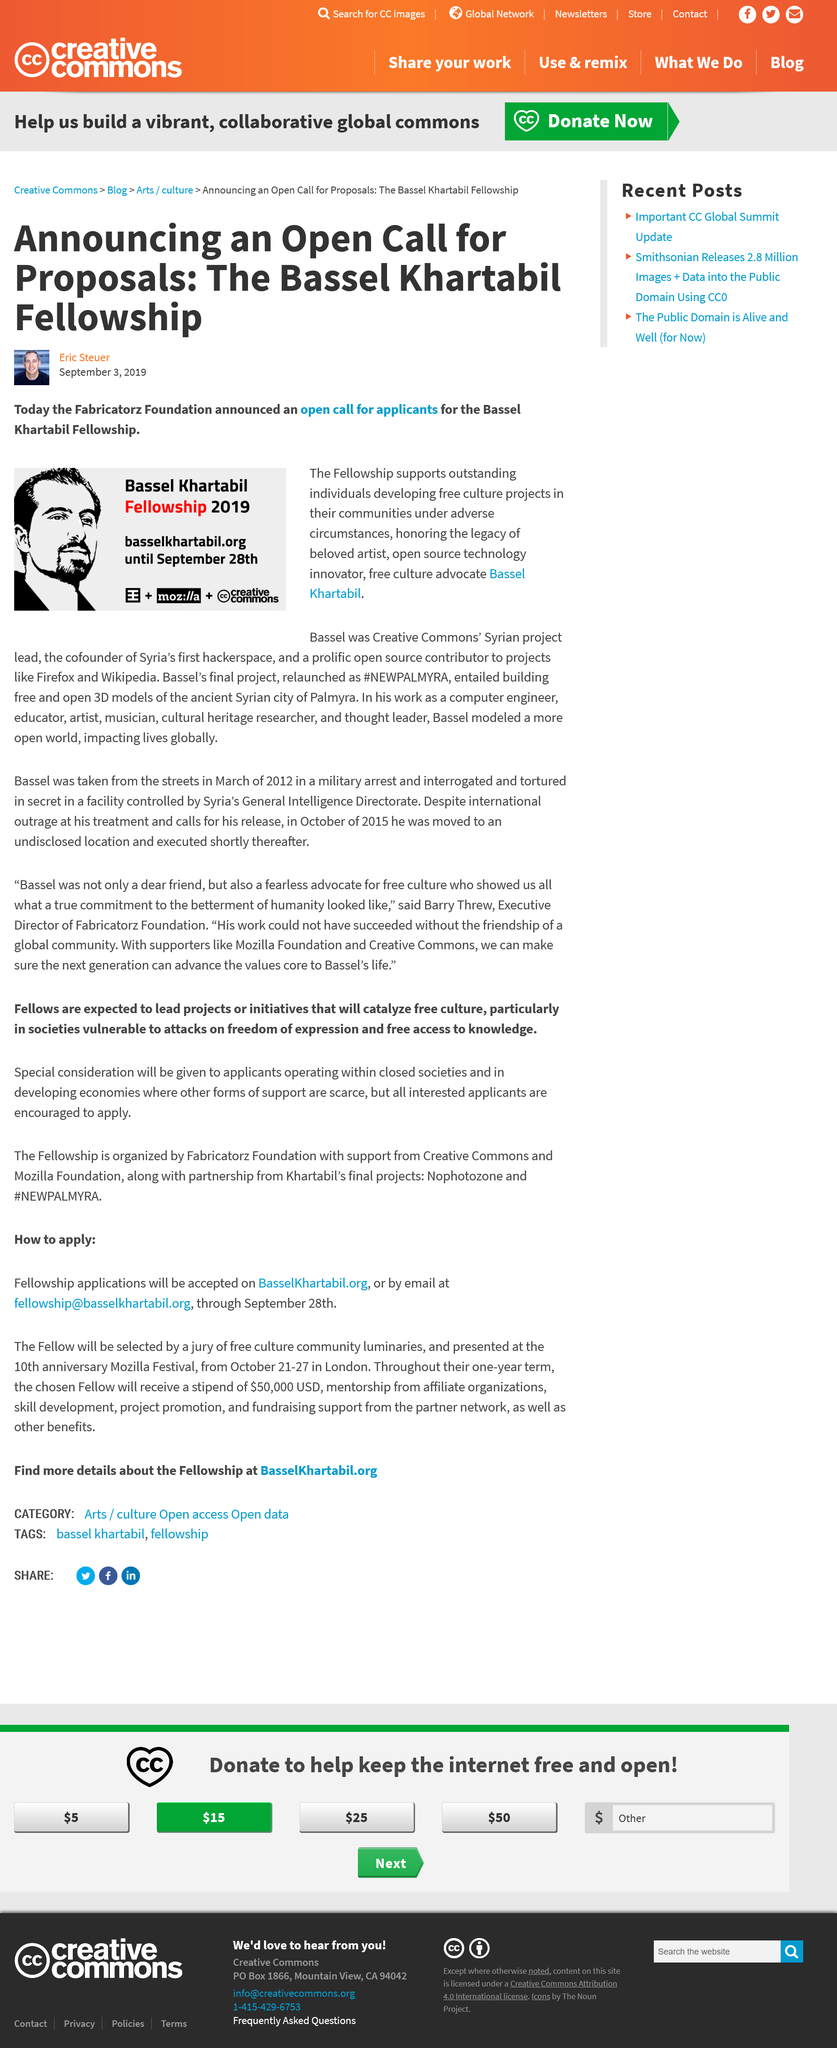Outline some significant characteristics in this image. On September 3rd, 2019, the Fabricatorz Foundation announced an open call for applicants for the Bassel Khartabil Fellowship. Bassel Khartabil was the co-founder of Syria's first hackerspace, which was established in 2007. He was an influential figure in the country's technology community and played a critical role in promoting open-source software and collaborative innovation in Syria. Bassel Khartabil, as part of the #NEWPALMYRA project, created free and open 3D models of the ancient Syrian city of Palmyra. 